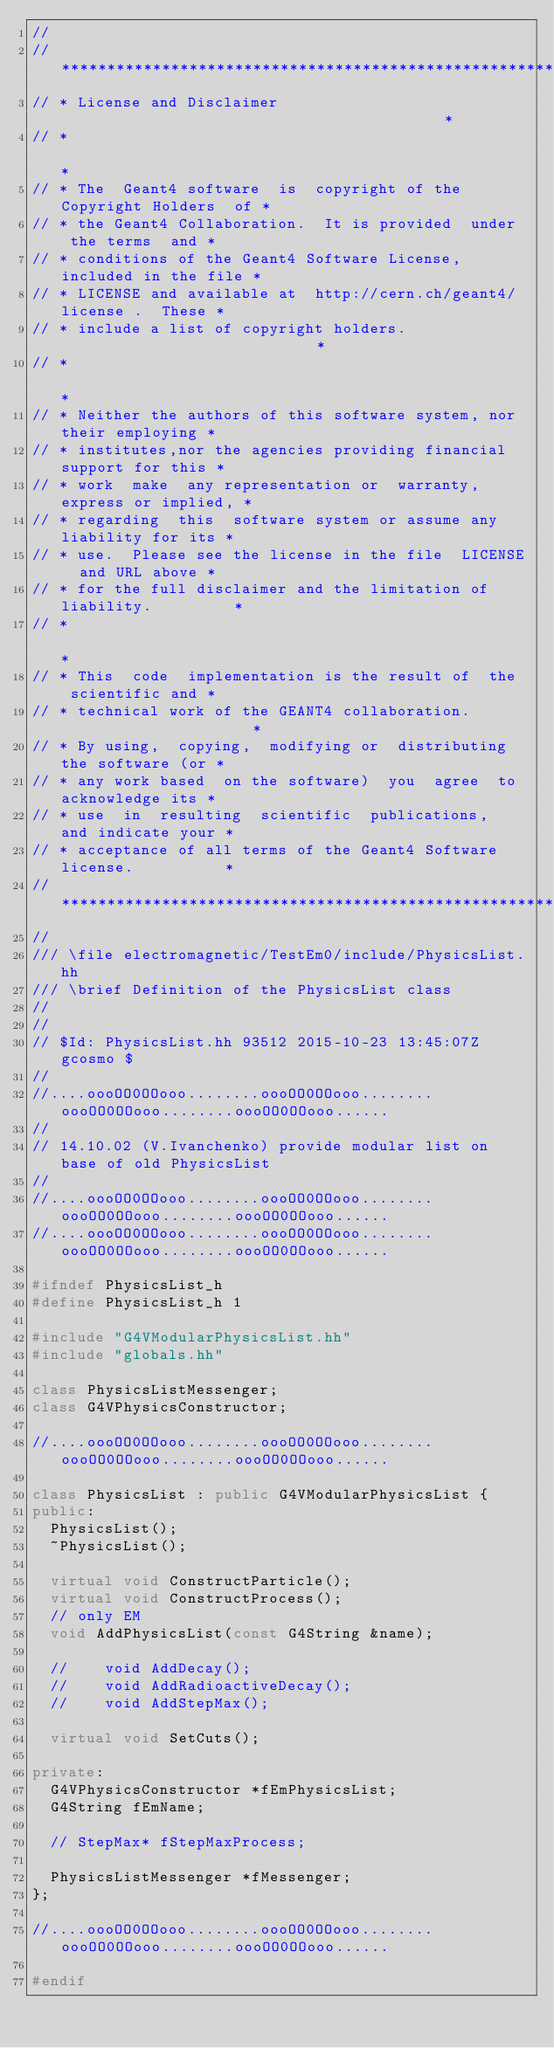<code> <loc_0><loc_0><loc_500><loc_500><_C++_>//
// ********************************************************************
// * License and Disclaimer                                           *
// *                                                                  *
// * The  Geant4 software  is  copyright of the Copyright Holders  of *
// * the Geant4 Collaboration.  It is provided  under  the terms  and *
// * conditions of the Geant4 Software License,  included in the file *
// * LICENSE and available at  http://cern.ch/geant4/license .  These *
// * include a list of copyright holders.                             *
// *                                                                  *
// * Neither the authors of this software system, nor their employing *
// * institutes,nor the agencies providing financial support for this *
// * work  make  any representation or  warranty, express or implied, *
// * regarding  this  software system or assume any liability for its *
// * use.  Please see the license in the file  LICENSE  and URL above *
// * for the full disclaimer and the limitation of liability.         *
// *                                                                  *
// * This  code  implementation is the result of  the  scientific and *
// * technical work of the GEANT4 collaboration.                      *
// * By using,  copying,  modifying or  distributing the software (or *
// * any work based  on the software)  you  agree  to acknowledge its *
// * use  in  resulting  scientific  publications,  and indicate your *
// * acceptance of all terms of the Geant4 Software license.          *
// ********************************************************************
//
/// \file electromagnetic/TestEm0/include/PhysicsList.hh
/// \brief Definition of the PhysicsList class
//
//
// $Id: PhysicsList.hh 93512 2015-10-23 13:45:07Z gcosmo $
//
//....oooOO0OOooo........oooOO0OOooo........oooOO0OOooo........oooOO0OOooo......
//
// 14.10.02 (V.Ivanchenko) provide modular list on base of old PhysicsList
//
//....oooOO0OOooo........oooOO0OOooo........oooOO0OOooo........oooOO0OOooo......
//....oooOO0OOooo........oooOO0OOooo........oooOO0OOooo........oooOO0OOooo......

#ifndef PhysicsList_h
#define PhysicsList_h 1

#include "G4VModularPhysicsList.hh"
#include "globals.hh"

class PhysicsListMessenger;
class G4VPhysicsConstructor;

//....oooOO0OOooo........oooOO0OOooo........oooOO0OOooo........oooOO0OOooo......

class PhysicsList : public G4VModularPhysicsList {
public:
  PhysicsList();
  ~PhysicsList();

  virtual void ConstructParticle();
  virtual void ConstructProcess();
  // only EM
  void AddPhysicsList(const G4String &name);

  //    void AddDecay();
  //    void AddRadioactiveDecay();
  //    void AddStepMax();

  virtual void SetCuts();

private:
  G4VPhysicsConstructor *fEmPhysicsList;
  G4String fEmName;

  // StepMax* fStepMaxProcess;

  PhysicsListMessenger *fMessenger;
};

//....oooOO0OOooo........oooOO0OOooo........oooOO0OOooo........oooOO0OOooo......

#endif
</code> 